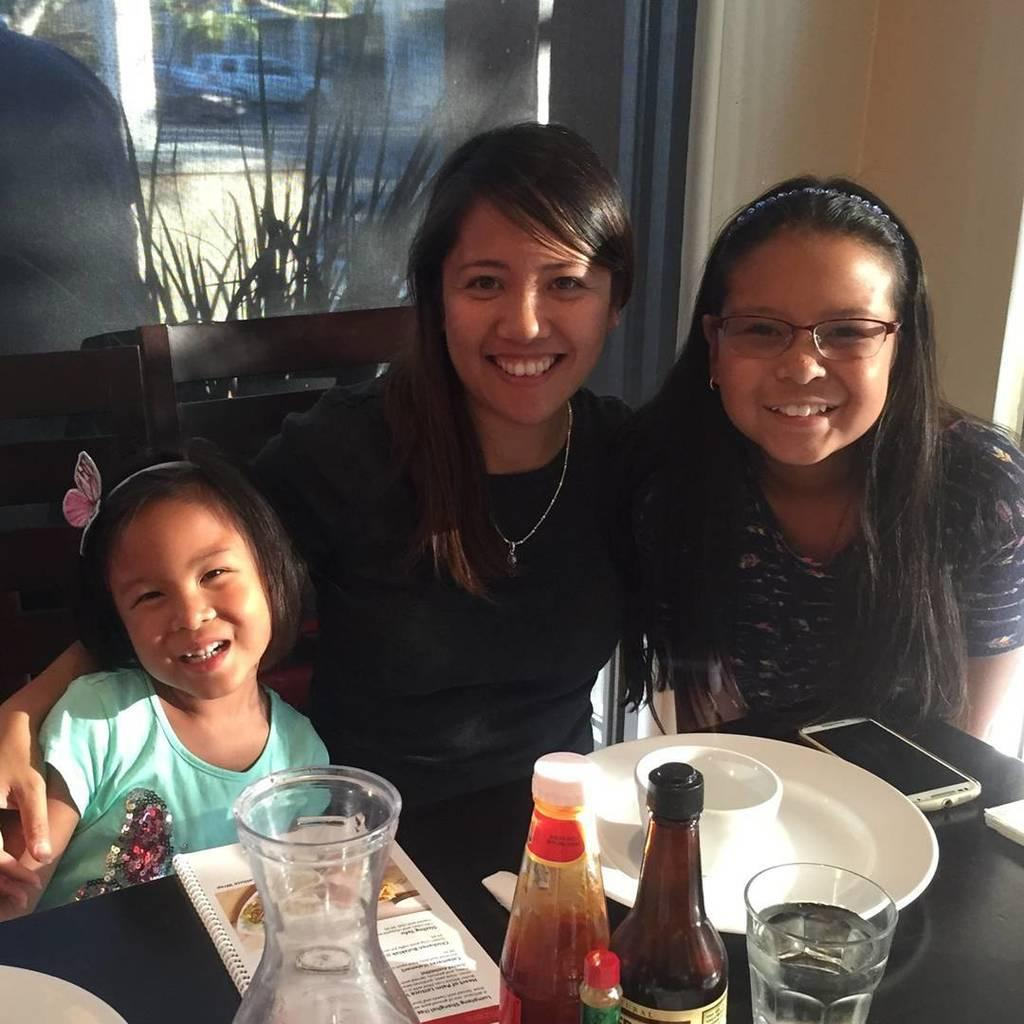How many people are in the image? There are two ladies and a kid in the image, making a total of three people. What are the ladies and the kid doing in the image? The ladies and the kid are sitting in chairs in the image. What is present on the table in front of them? There is a phone, a plate, a glass, a sauce bottle, and a book on the table. Can you see a horse running in the background of the image? There is no horse or any background visible in the image; it only shows the ladies, the kid, and the table with objects. 